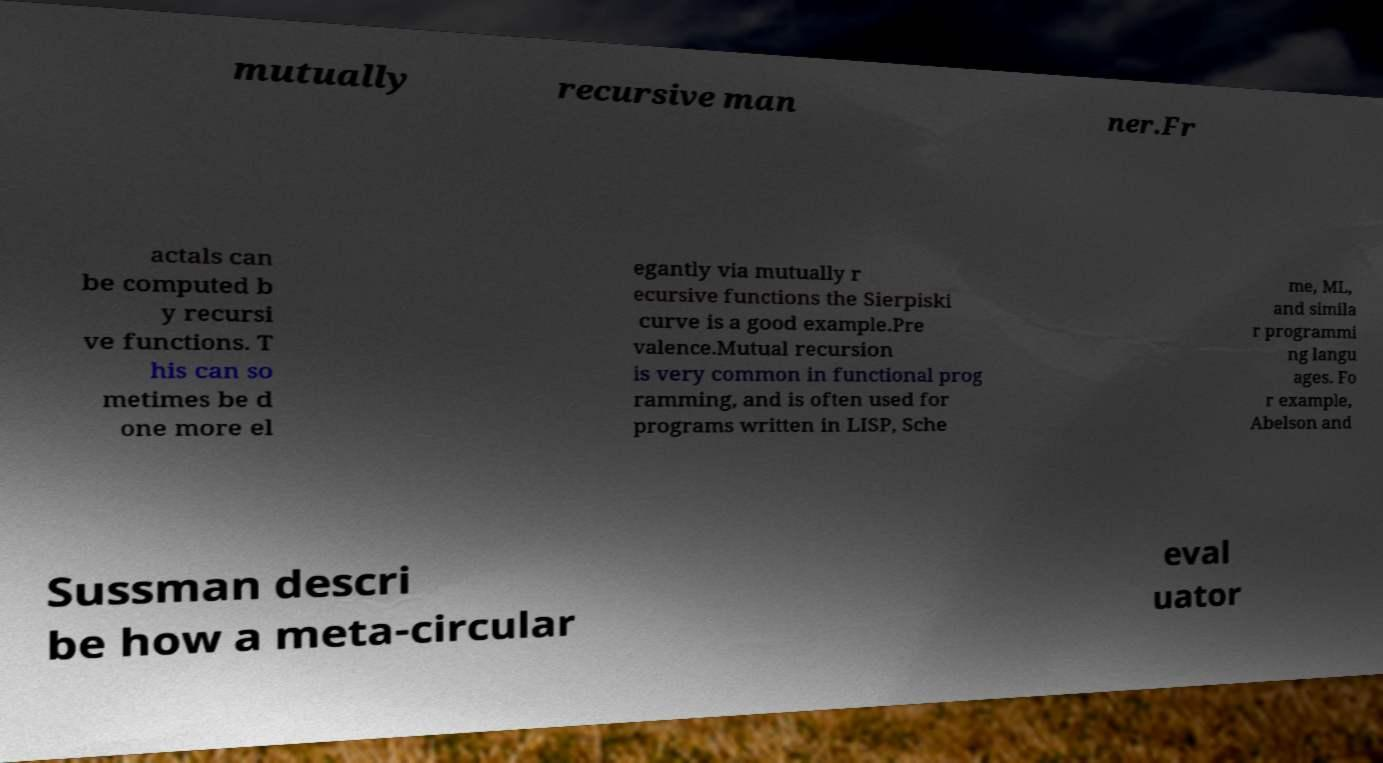Please read and relay the text visible in this image. What does it say? mutually recursive man ner.Fr actals can be computed b y recursi ve functions. T his can so metimes be d one more el egantly via mutually r ecursive functions the Sierpiski curve is a good example.Pre valence.Mutual recursion is very common in functional prog ramming, and is often used for programs written in LISP, Sche me, ML, and simila r programmi ng langu ages. Fo r example, Abelson and Sussman descri be how a meta-circular eval uator 